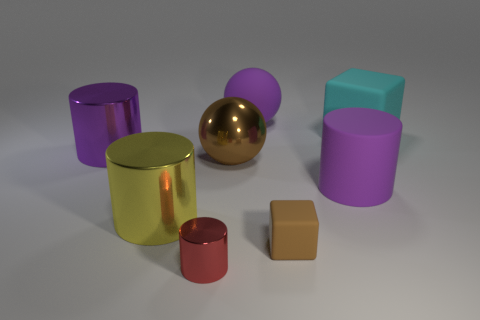Subtract all blue cubes. Subtract all gray balls. How many cubes are left? 2 Add 1 tiny cyan matte spheres. How many objects exist? 9 Subtract all balls. How many objects are left? 6 Subtract 1 brown balls. How many objects are left? 7 Subtract all large green metal cylinders. Subtract all large rubber objects. How many objects are left? 5 Add 6 tiny cubes. How many tiny cubes are left? 7 Add 2 red matte cubes. How many red matte cubes exist? 2 